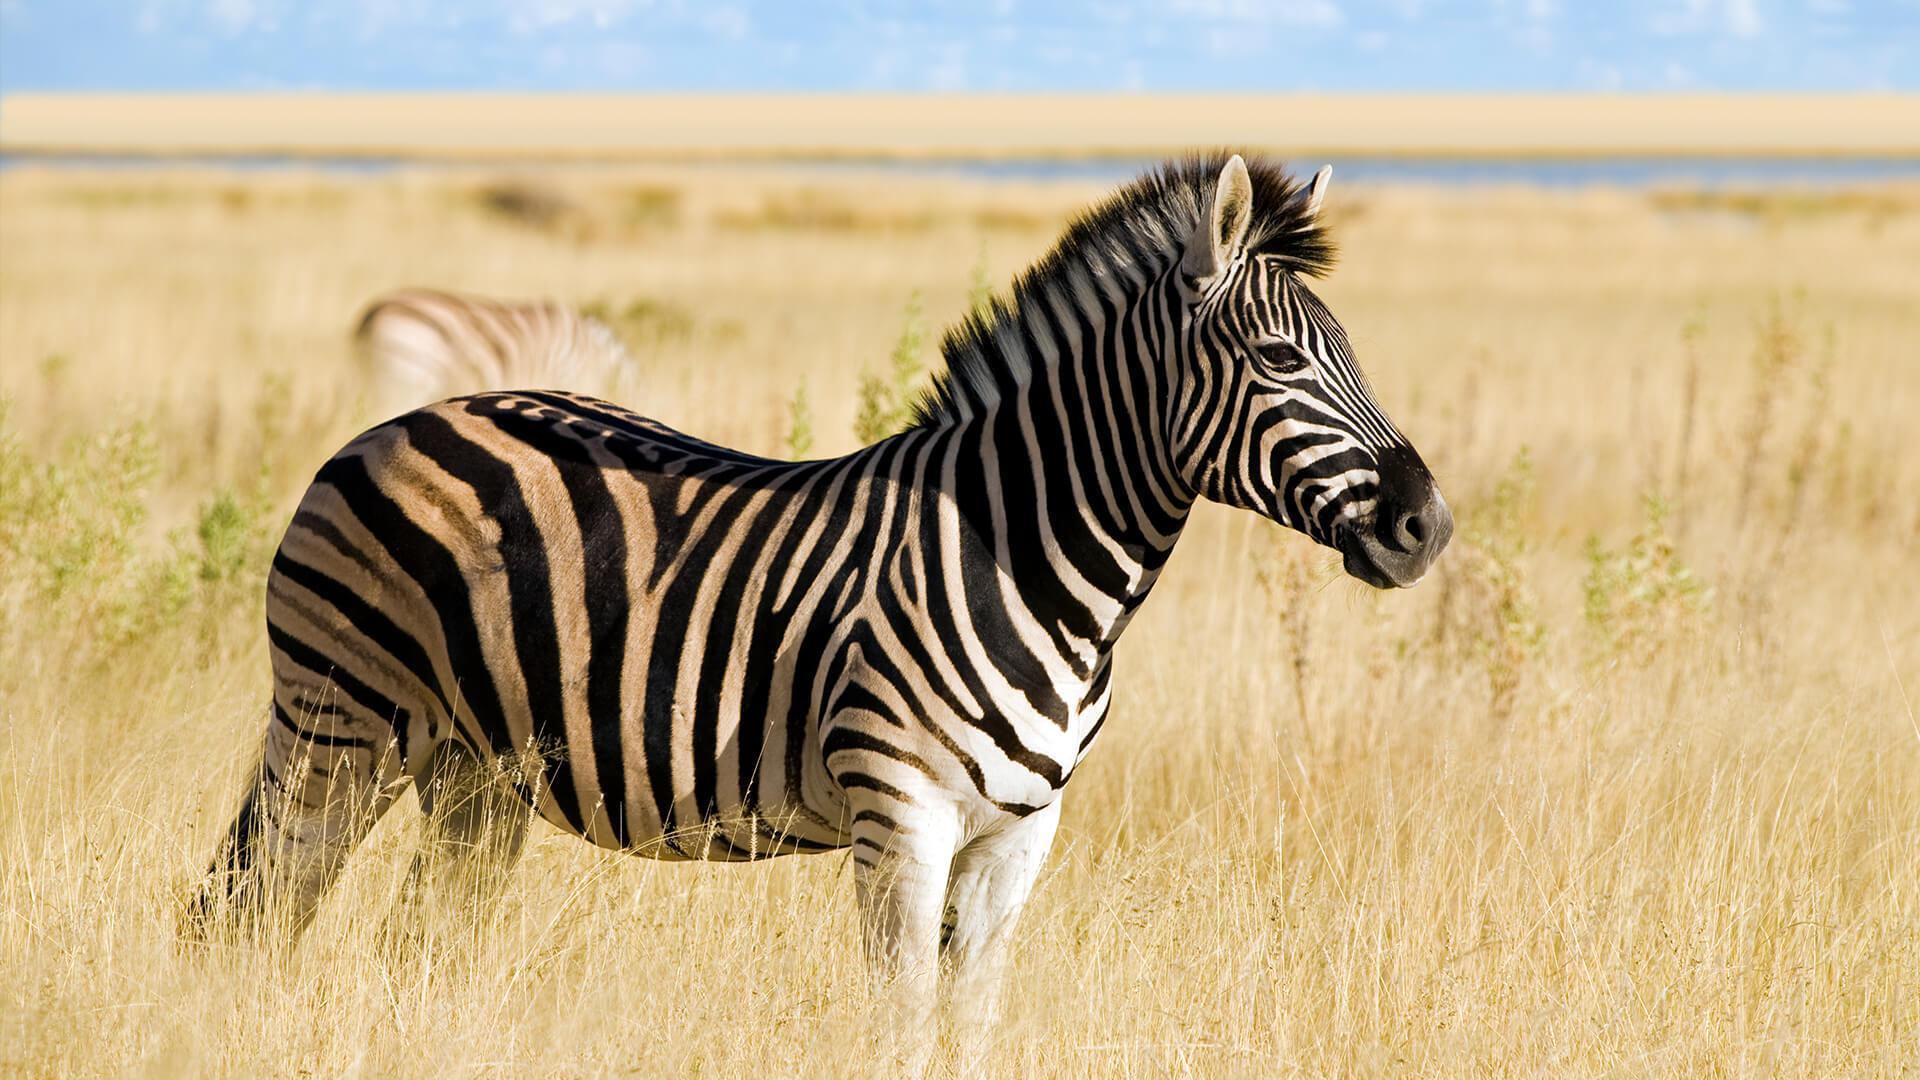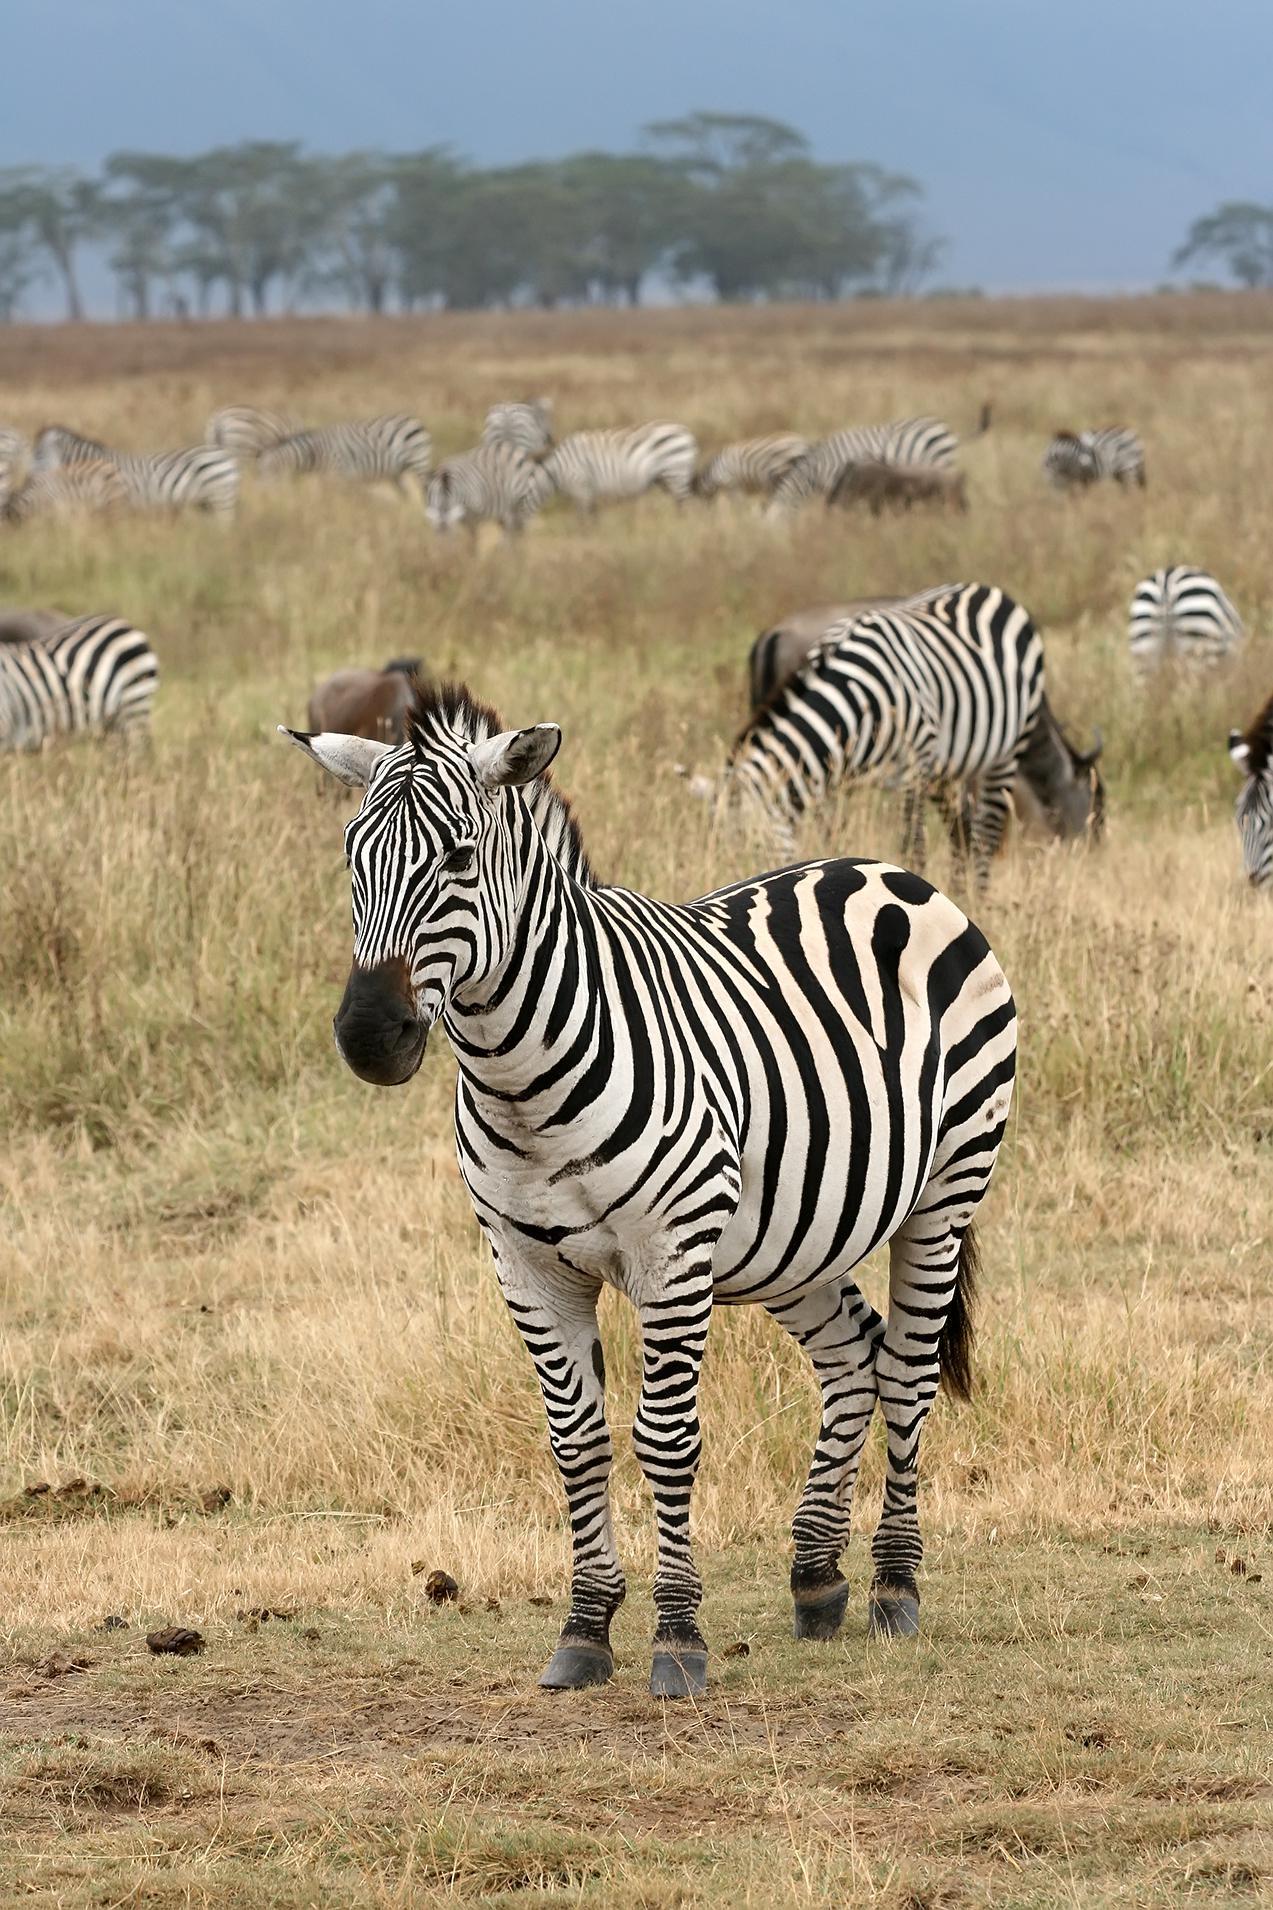The first image is the image on the left, the second image is the image on the right. Examine the images to the left and right. Is the description "There is a mother zebra standing in the grass with her baby close to her" accurate? Answer yes or no. No. The first image is the image on the left, the second image is the image on the right. For the images displayed, is the sentence "The right image contains only one zebra." factually correct? Answer yes or no. No. 